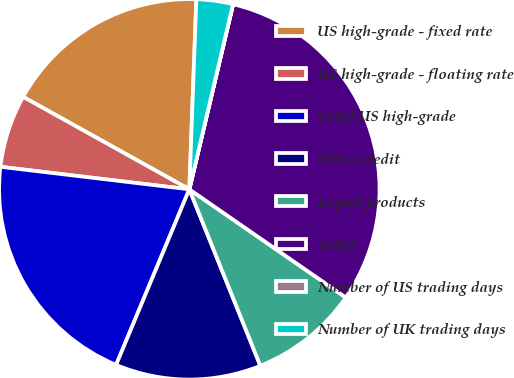Convert chart to OTSL. <chart><loc_0><loc_0><loc_500><loc_500><pie_chart><fcel>US high-grade - fixed rate<fcel>US high-grade - floating rate<fcel>Total US high-grade<fcel>Other credit<fcel>Liquid products<fcel>Total<fcel>Number of US trading days<fcel>Number of UK trading days<nl><fcel>17.51%<fcel>6.19%<fcel>20.6%<fcel>12.38%<fcel>9.28%<fcel>30.93%<fcel>0.01%<fcel>3.1%<nl></chart> 